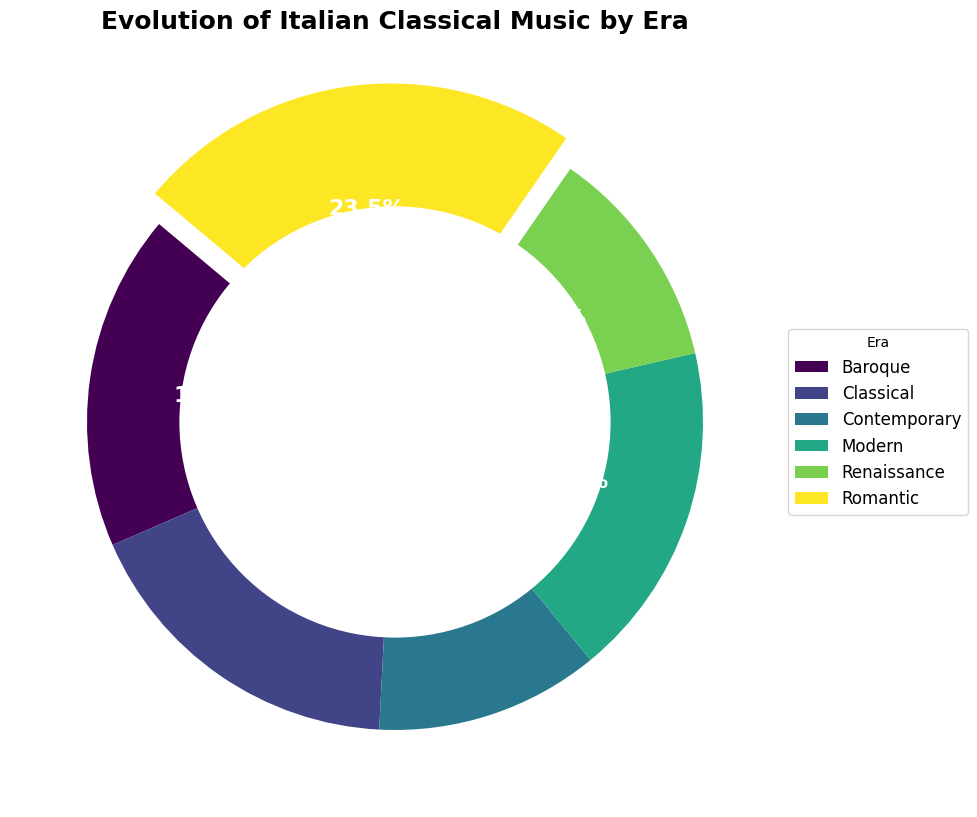Which era has the highest percentage of key composers in the figure? Observe the slice that is most prominent in size and is exploded outwards the most in the ring chart. This visual cue indicates that the Romantic era has the highest contribution.
Answer: Romantic Compare the contributions of the Baroque and Classical eras. Which one is greater? Look at the sizes of the slices for both the Baroque and Classical eras. The segment for the Baroque era is larger, hence it has more key composers than the Classical era.
Answer: Baroque What era does the lightest color in the figure represent? Observe the lightest colored segment in the ring chart. This color represents the Contemporary era.
Answer: Contemporary How do the contributions of the Renaissance and Modern eras compare in percentage terms? Locate both the Renaissance and Modern era slices and compare their sizes. The Renaissance era slice is larger, indicating it has a higher percentage of key composers than the Modern era.
Answer: Renaissance What is the combined percentage contribution of the Classical and Modern eras? Identify the individual percentages for the Classical and Modern era slices. Sum both percentages: around 18.8 % (Classical) + 18.8 % (Modern) = 37.6 %.
Answer: 37.6% Which two eras have an equal percentage of key composers? Observe the slices and the percentages labeled on them. The Classical and Modern eras both have equal percentage contributions.
Answer: Classical and Modern Which era has a smaller percentage of composers than the Renaissance era but more than the Classical era? Compare the slice sizes. The Baroque era has a smaller percentage than the Renaissance but a greater percentage than the Classical era.
Answer: Baroque What is the percentage difference between the Romantic and Contemporary eras? Determine the percentages for both the Romantic and Contemporary eras. Subtract the Contemporary era percentage from the Romantic era percentage: about 31.3% - 12.5% = 18.8%.
Answer: 18.8% 